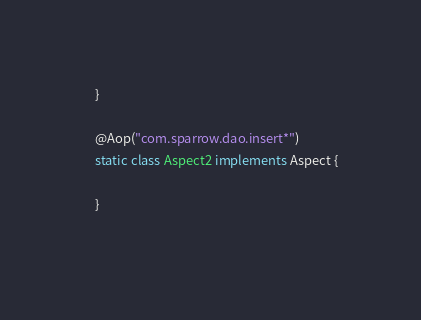<code> <loc_0><loc_0><loc_500><loc_500><_Java_>	}
	
	@Aop("com.sparrow.dao.insert*")
	static class Aspect2 implements Aspect {
		
	}
	</code> 